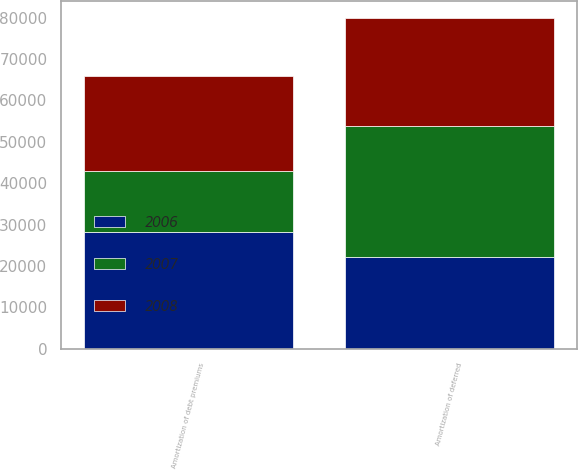Convert chart. <chart><loc_0><loc_0><loc_500><loc_500><stacked_bar_chart><ecel><fcel>Amortization of deferred<fcel>Amortization of debt premiums<nl><fcel>2007<fcel>31674<fcel>14701<nl><fcel>2008<fcel>26033<fcel>23000<nl><fcel>2006<fcel>22259<fcel>28163<nl></chart> 